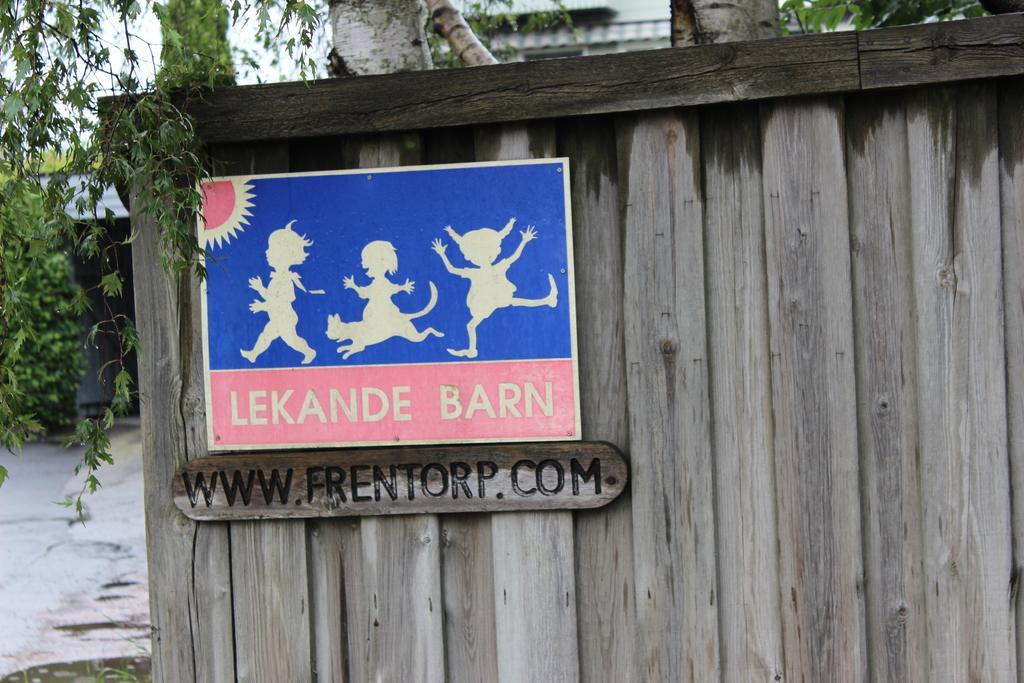Can you describe this image briefly? In this image we can see the boards on a wooden wall with some pictures and text on them. We can also see the bark of the trees, a building, some trees and the sky. On the bottom of the image we can see some water on the ground. 